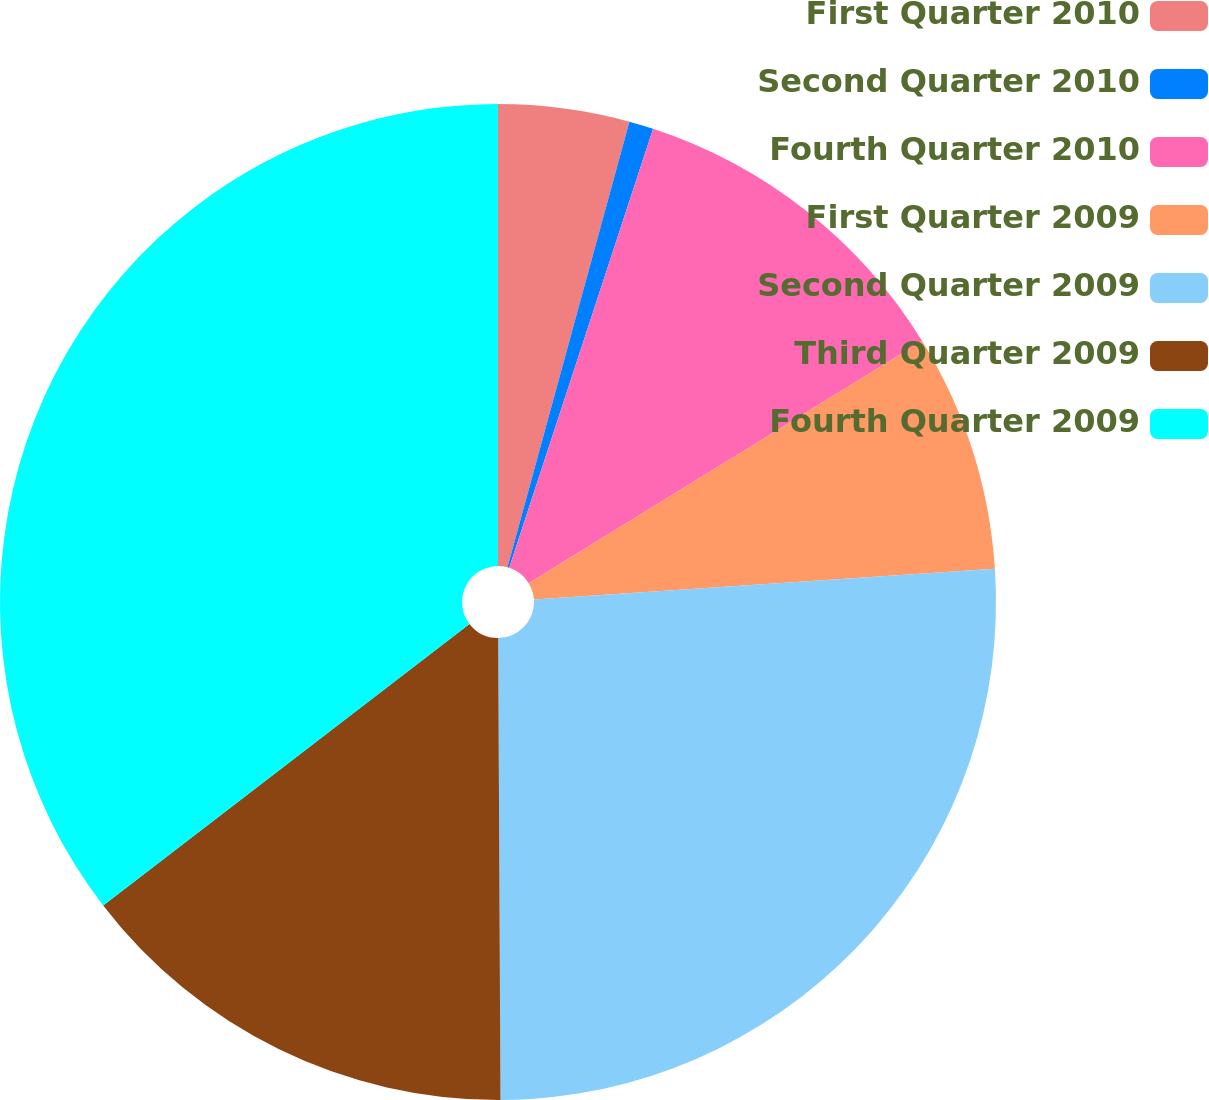<chart> <loc_0><loc_0><loc_500><loc_500><pie_chart><fcel>First Quarter 2010<fcel>Second Quarter 2010<fcel>Fourth Quarter 2010<fcel>First Quarter 2009<fcel>Second Quarter 2009<fcel>Third Quarter 2009<fcel>Fourth Quarter 2009<nl><fcel>4.25%<fcel>0.79%<fcel>11.18%<fcel>7.72%<fcel>25.98%<fcel>14.65%<fcel>35.43%<nl></chart> 